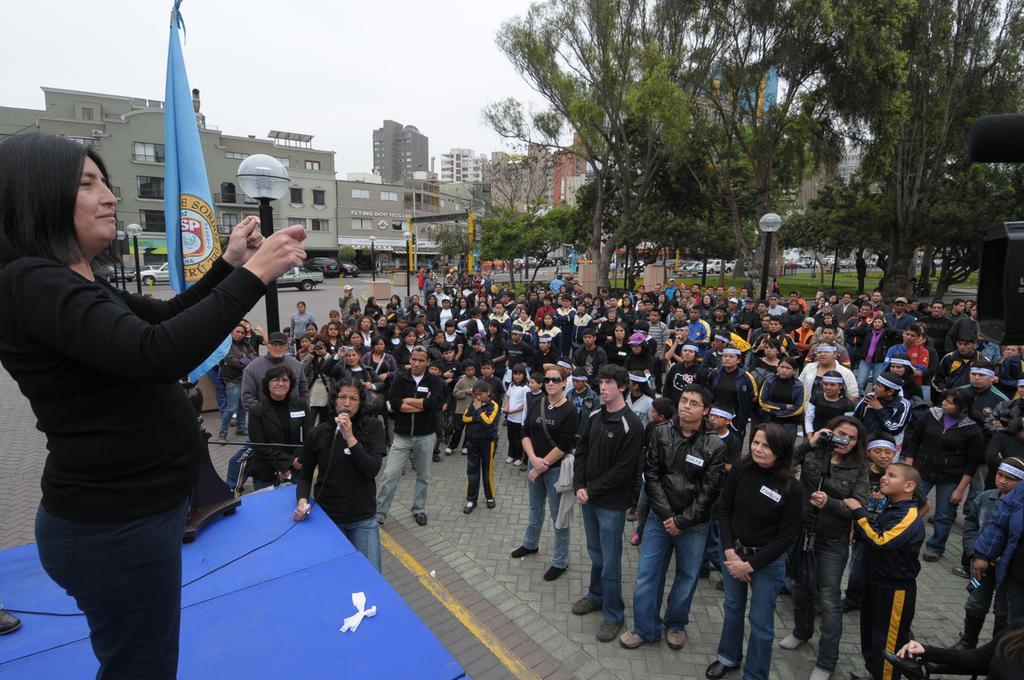How would you summarize this image in a sentence or two? In this picture there are group of people standing and there is a person standing and holding the microphone. On the left side of the image there is a person standing on the stage and there is a flag on the stage. At the back there are buildings, trees and poles and there are vehicles on the road. At the top there is sky. At the bottom there is a road and there is grass. 